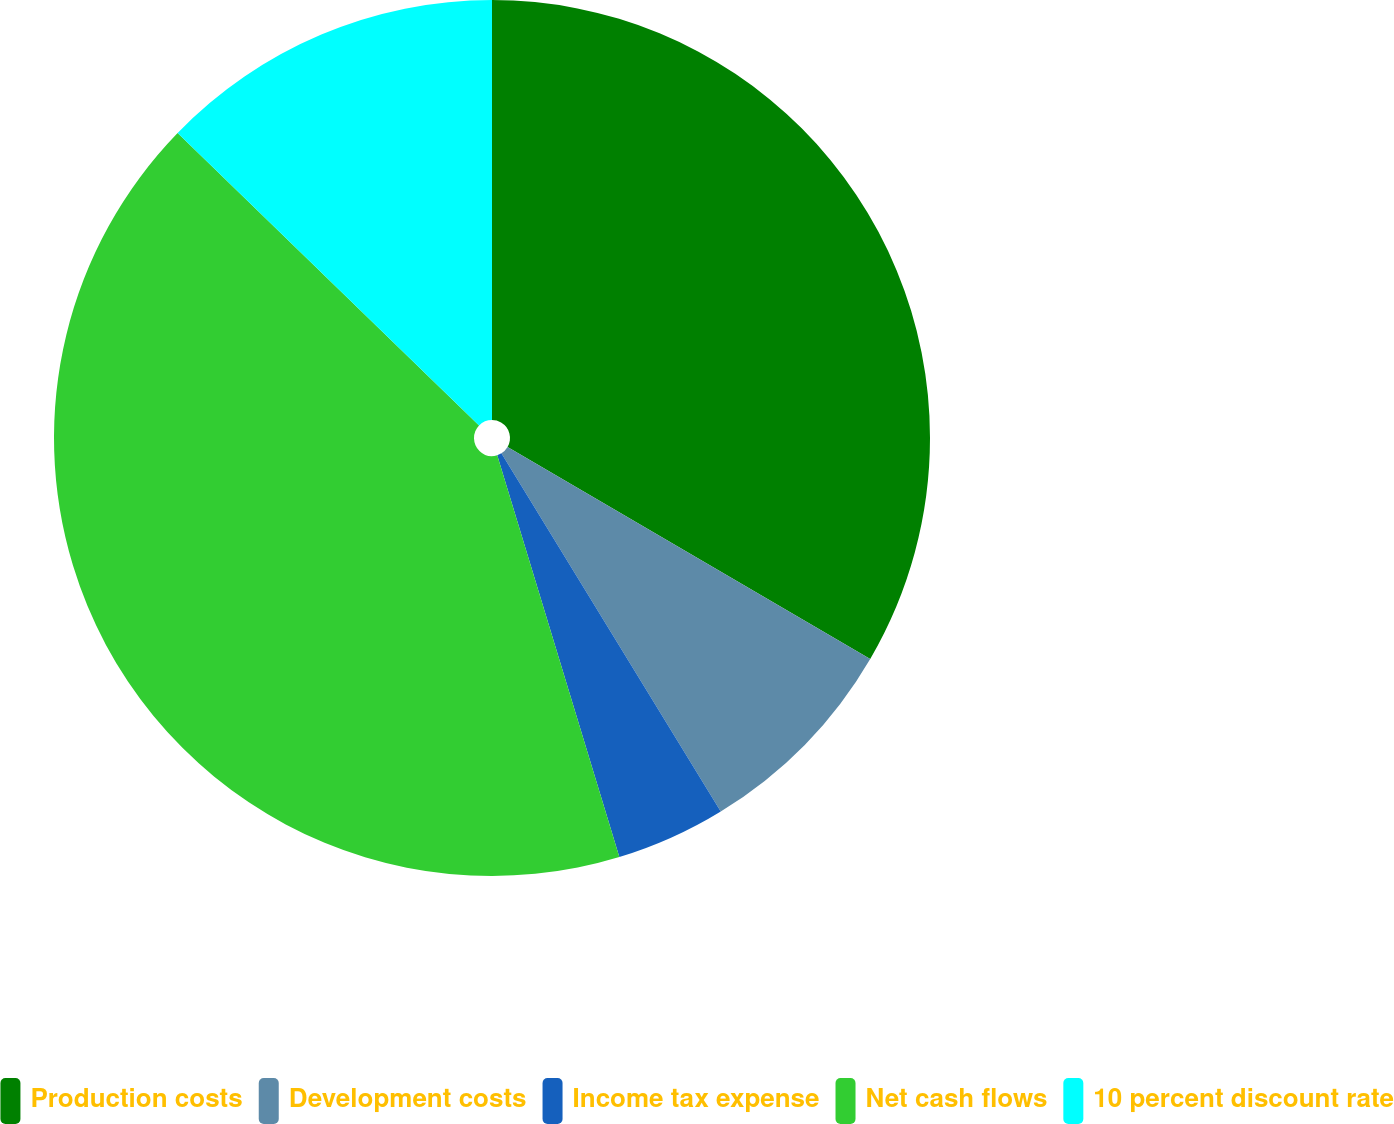Convert chart. <chart><loc_0><loc_0><loc_500><loc_500><pie_chart><fcel>Production costs<fcel>Development costs<fcel>Income tax expense<fcel>Net cash flows<fcel>10 percent discount rate<nl><fcel>33.41%<fcel>7.84%<fcel>4.05%<fcel>41.95%<fcel>12.74%<nl></chart> 